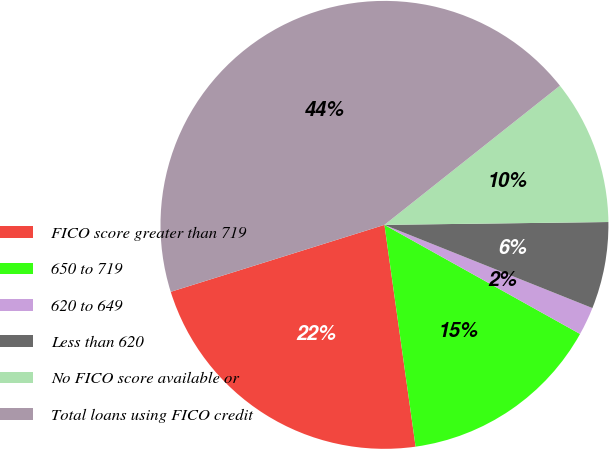Convert chart. <chart><loc_0><loc_0><loc_500><loc_500><pie_chart><fcel>FICO score greater than 719<fcel>650 to 719<fcel>620 to 649<fcel>Less than 620<fcel>No FICO score available or<fcel>Total loans using FICO credit<nl><fcel>22.39%<fcel>14.68%<fcel>2.04%<fcel>6.26%<fcel>10.47%<fcel>44.16%<nl></chart> 